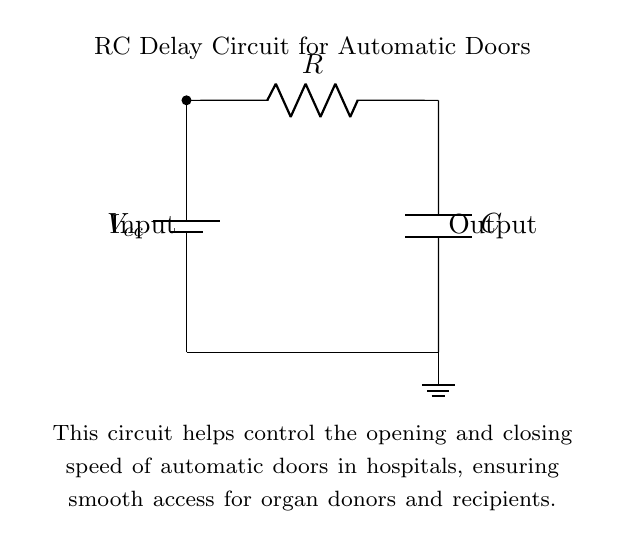What is the power supply type in this circuit? The circuit uses a battery as the power supply, which is indicated by the symbol in the diagram.
Answer: Battery What components are present in the circuit? The circuit contains a resistor and a capacitor, which are essential components in an RC delay circuit.
Answer: Resistor and Capacitor What is the purpose of the capacitor in this circuit? The capacitor stores charge to create a delay in the circuit, affecting how quickly the automatic doors open or close.
Answer: Delay What does the label "Input" indicate? The "Input" label indicates where the control signal enters the circuit to initiate the operation of the automatic doors.
Answer: Control signal entry How does the RC time constant affect the circuit's operation? The RC time constant, calculated by multiplying resistance and capacitance, determines the speed at which the capacitor charges or discharges, thus controlling the timing for door operation.
Answer: Speed of operation What happens when the capacitor fully charges? When the capacitor fully charges, the output signal changes state, typically activating or deactivating the motor for the door mechanism.
Answer: Changes state 